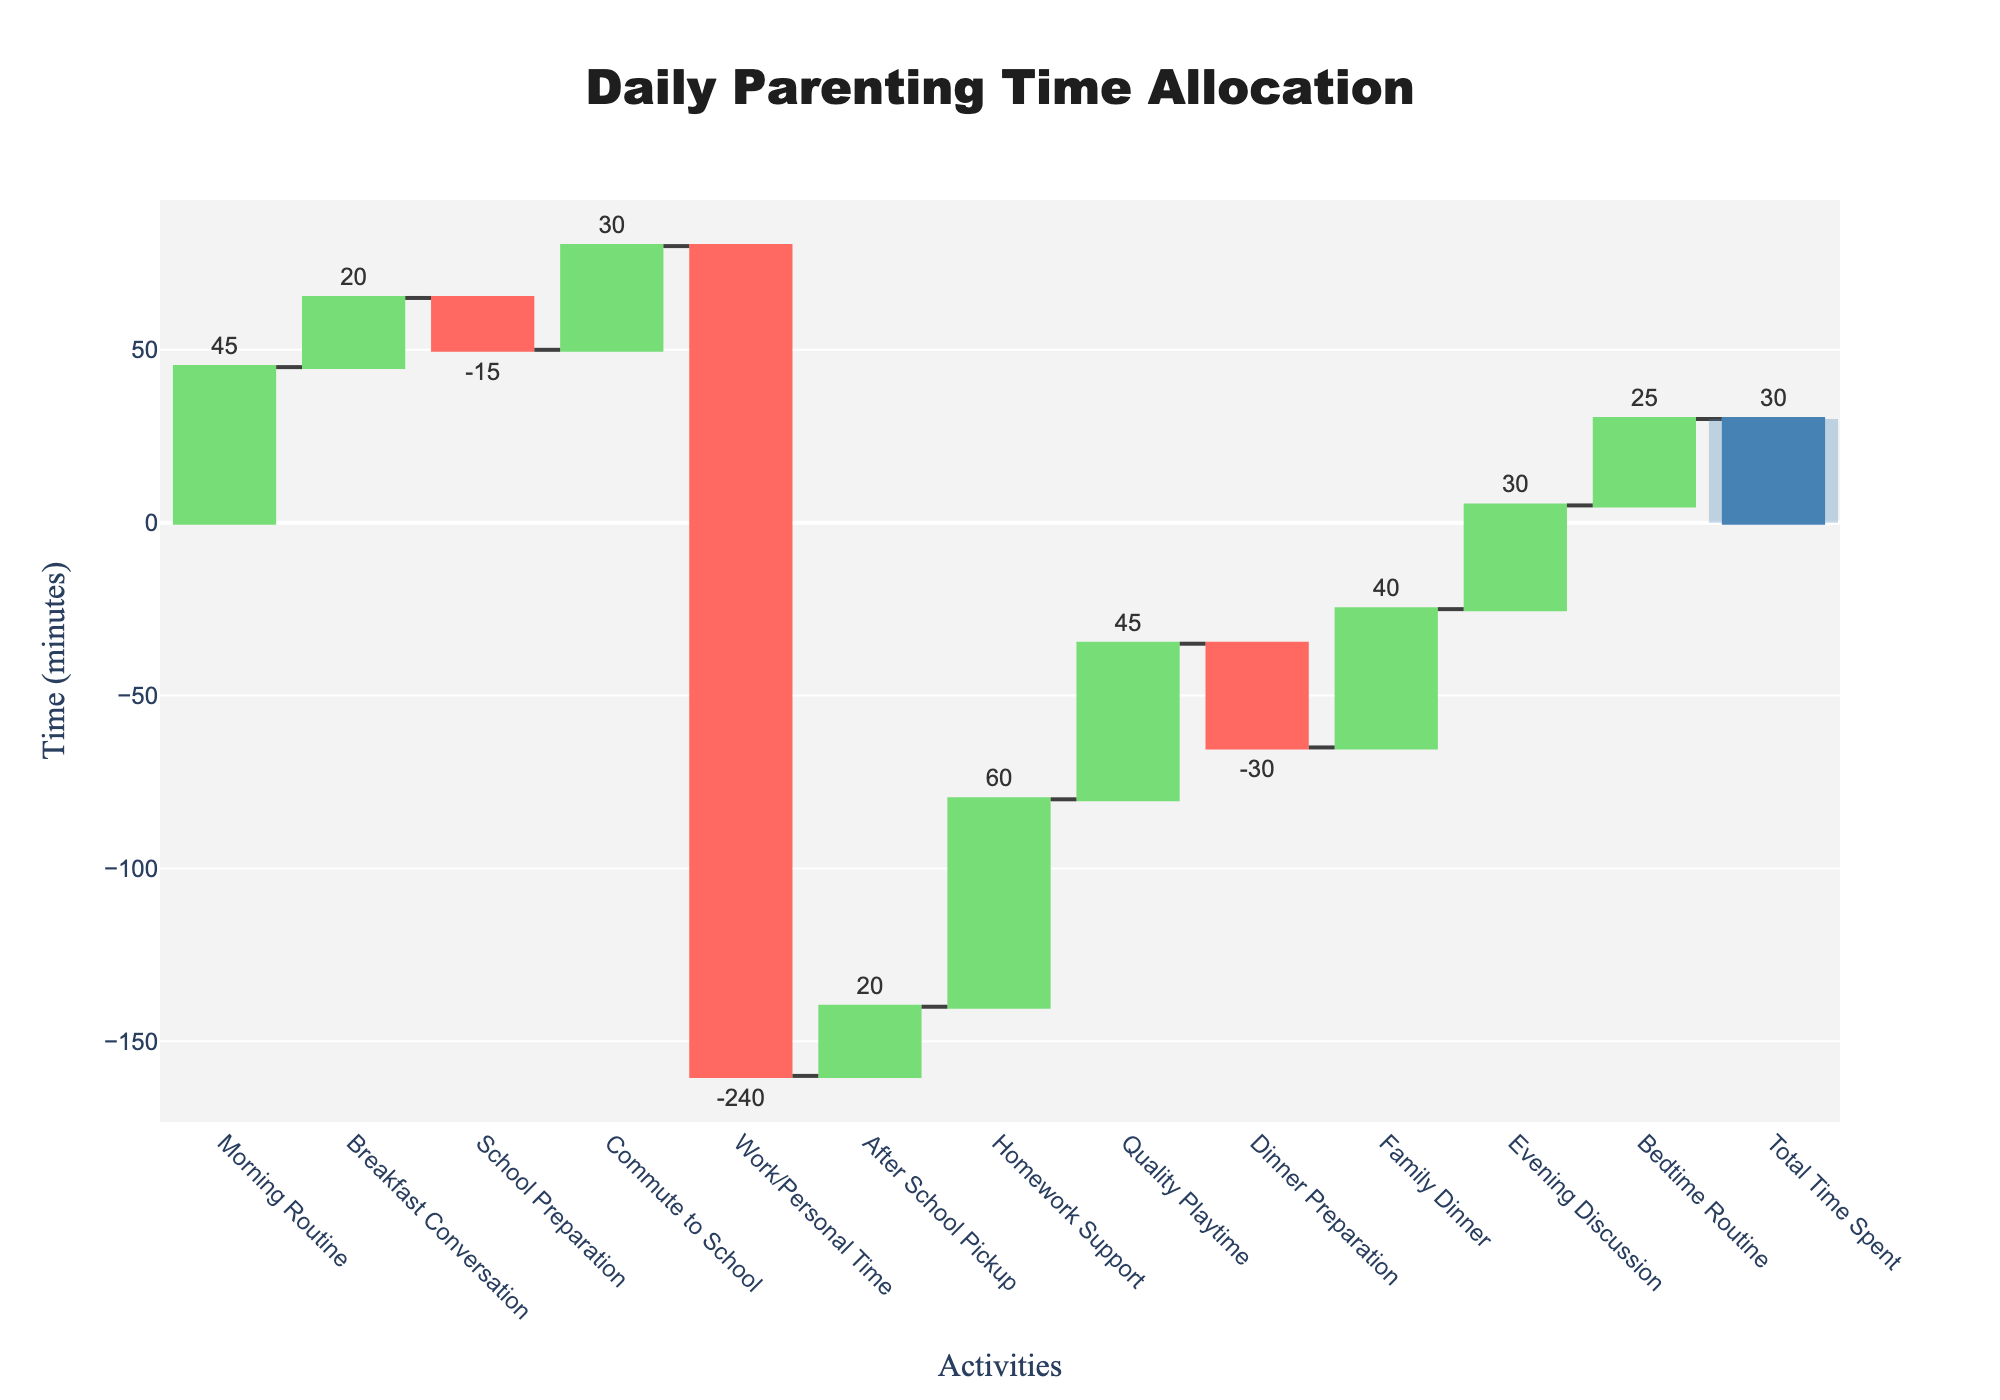What is the title of the waterfall chart? The title is found at the top of the chart, which explains what the chart is about.
Answer: Daily Parenting Time Allocation How much time is spent on the morning routine? Locate the bar labeled "Morning Routine" and check the value associated with it.
Answer: 45 minutes What activity results in the highest decrease in time spent? Identify the bars with negative values and find the one with the largest decrease.
Answer: Work/Personal Time What is the total time spent according to the chart? Look for the bar labeled "Total Time Spent" which sums all the activities.
Answer: 30 minutes Which activity has the smallest positive contribution to the total time spent? Among the positive values, find the smallest one.
Answer: Breakfast Conversation How much time is spent on both the morning routine and quality playtime combined? Add the time spent on "Morning Routine" and "Quality Playtime".
Answer: 45 + 45 = 90 minutes What is the net impact on time between school preparation and dinner preparation? Determine the difference between the time spent on "School Preparation" and "Dinner Preparation".
Answer: -15 - (-30) = 15 minutes Which activities are associated with evening time, and how much total time is spent on them? Identify the evening-related activities ("Family Dinner", "Evening Discussion", "Bedtime Routine") and sum their times.
Answer: 40 + 30 + 25 = 95 minutes What is the difference in time spent between the commute to school and after school pickup? Subtract the time spent on "After School Pickup" from "Commute to School".
Answer: 30 - 20 = 10 minutes Which two positive activities contribute equally to the total time spent? Identify the bars with the same positive values by comparing their heights and labels.
Answer: Morning Routine and Quality Playtime Both contribute 45 minutes each 